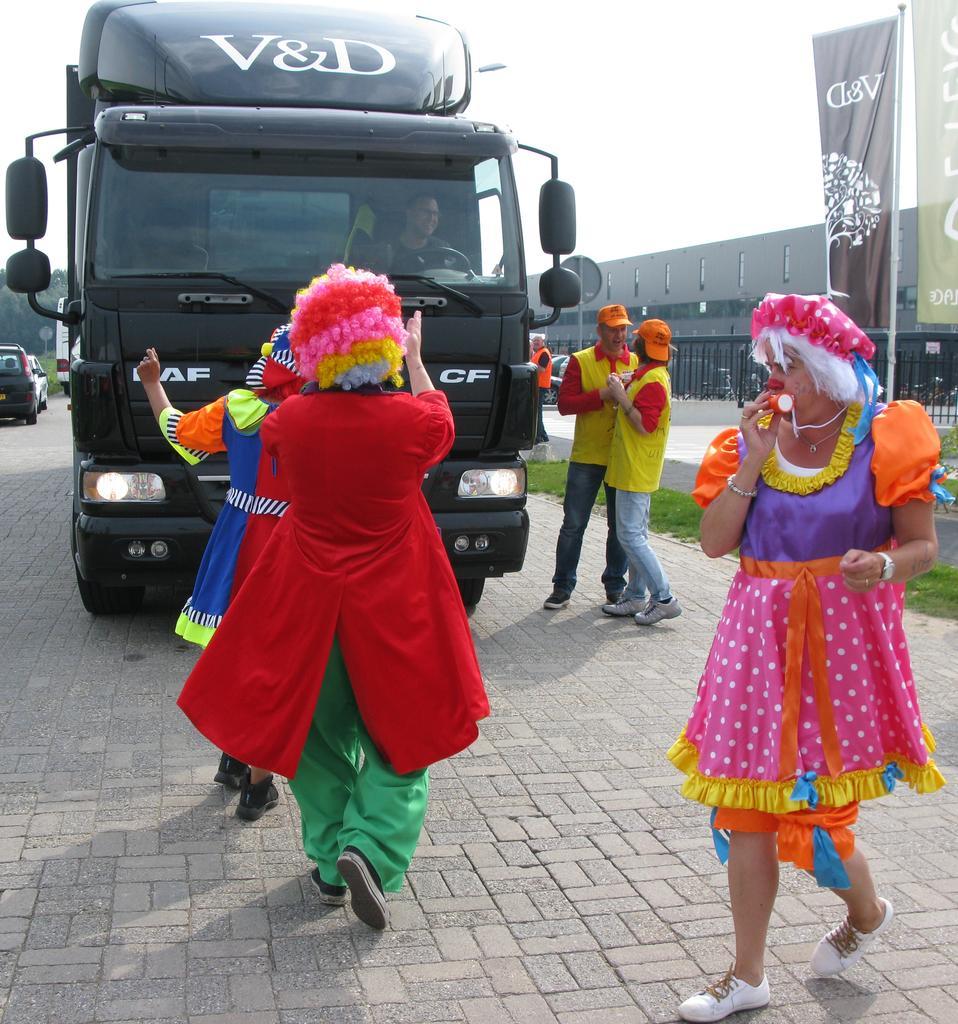Can you describe this image briefly? In this image, we can see some people standing, there is a truck, in the background, we can see cars, at the top there is a sky. 